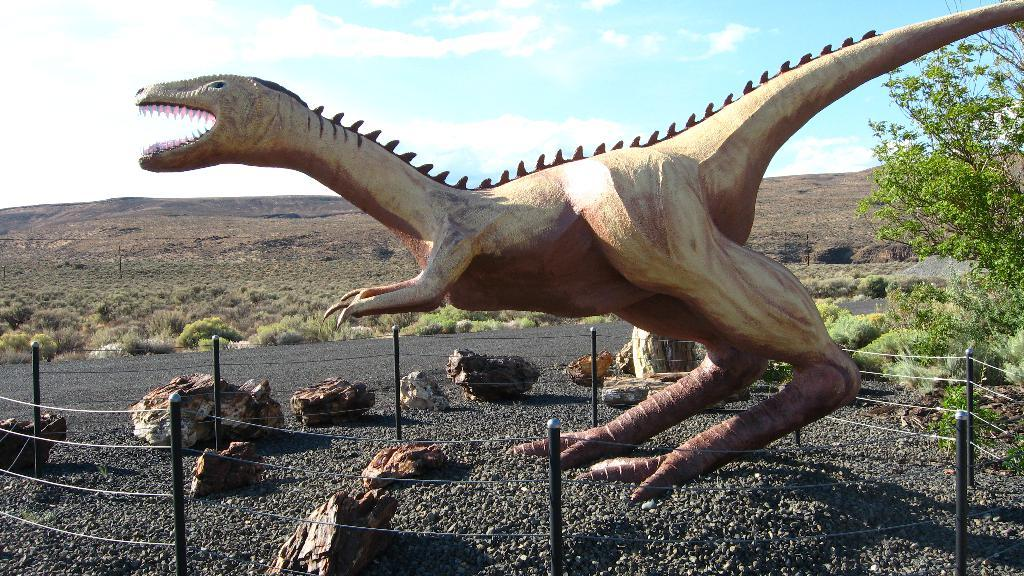What is the main subject of the image? There is a statue of a dinosaur in the image. What can be seen on the ground in the image? There are objects on the ground in the image. What type of natural environment is visible in the background of the image? There are trees in the background of the image. What is visible in the sky in the image? The sky is visible in the background of the image. How many snakes are coiled around the dinosaur statue in the image? There are no snakes present in the image; it features a statue of a dinosaur with no snakes visible. What type of coach is driving past the dinosaur statue in the image? There is no coach present in the image; it only features a statue of a dinosaur and objects on the ground. 